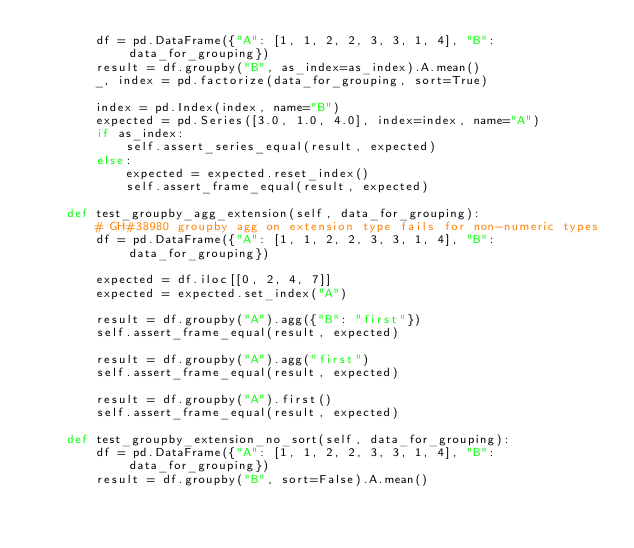Convert code to text. <code><loc_0><loc_0><loc_500><loc_500><_Python_>        df = pd.DataFrame({"A": [1, 1, 2, 2, 3, 3, 1, 4], "B": data_for_grouping})
        result = df.groupby("B", as_index=as_index).A.mean()
        _, index = pd.factorize(data_for_grouping, sort=True)

        index = pd.Index(index, name="B")
        expected = pd.Series([3.0, 1.0, 4.0], index=index, name="A")
        if as_index:
            self.assert_series_equal(result, expected)
        else:
            expected = expected.reset_index()
            self.assert_frame_equal(result, expected)

    def test_groupby_agg_extension(self, data_for_grouping):
        # GH#38980 groupby agg on extension type fails for non-numeric types
        df = pd.DataFrame({"A": [1, 1, 2, 2, 3, 3, 1, 4], "B": data_for_grouping})

        expected = df.iloc[[0, 2, 4, 7]]
        expected = expected.set_index("A")

        result = df.groupby("A").agg({"B": "first"})
        self.assert_frame_equal(result, expected)

        result = df.groupby("A").agg("first")
        self.assert_frame_equal(result, expected)

        result = df.groupby("A").first()
        self.assert_frame_equal(result, expected)

    def test_groupby_extension_no_sort(self, data_for_grouping):
        df = pd.DataFrame({"A": [1, 1, 2, 2, 3, 3, 1, 4], "B": data_for_grouping})
        result = df.groupby("B", sort=False).A.mean()</code> 